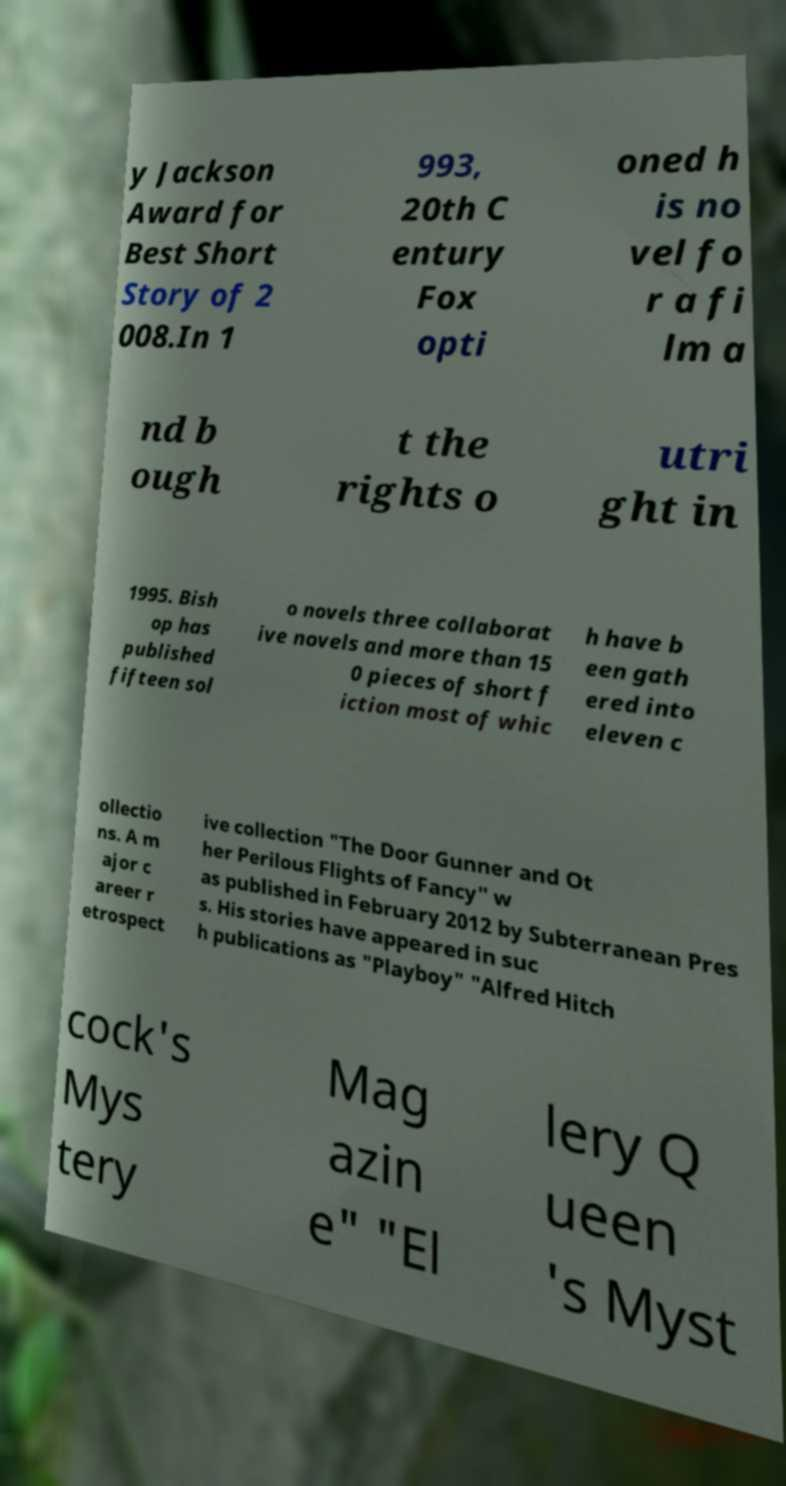Please identify and transcribe the text found in this image. y Jackson Award for Best Short Story of 2 008.In 1 993, 20th C entury Fox opti oned h is no vel fo r a fi lm a nd b ough t the rights o utri ght in 1995. Bish op has published fifteen sol o novels three collaborat ive novels and more than 15 0 pieces of short f iction most of whic h have b een gath ered into eleven c ollectio ns. A m ajor c areer r etrospect ive collection "The Door Gunner and Ot her Perilous Flights of Fancy" w as published in February 2012 by Subterranean Pres s. His stories have appeared in suc h publications as "Playboy" "Alfred Hitch cock's Mys tery Mag azin e" "El lery Q ueen 's Myst 